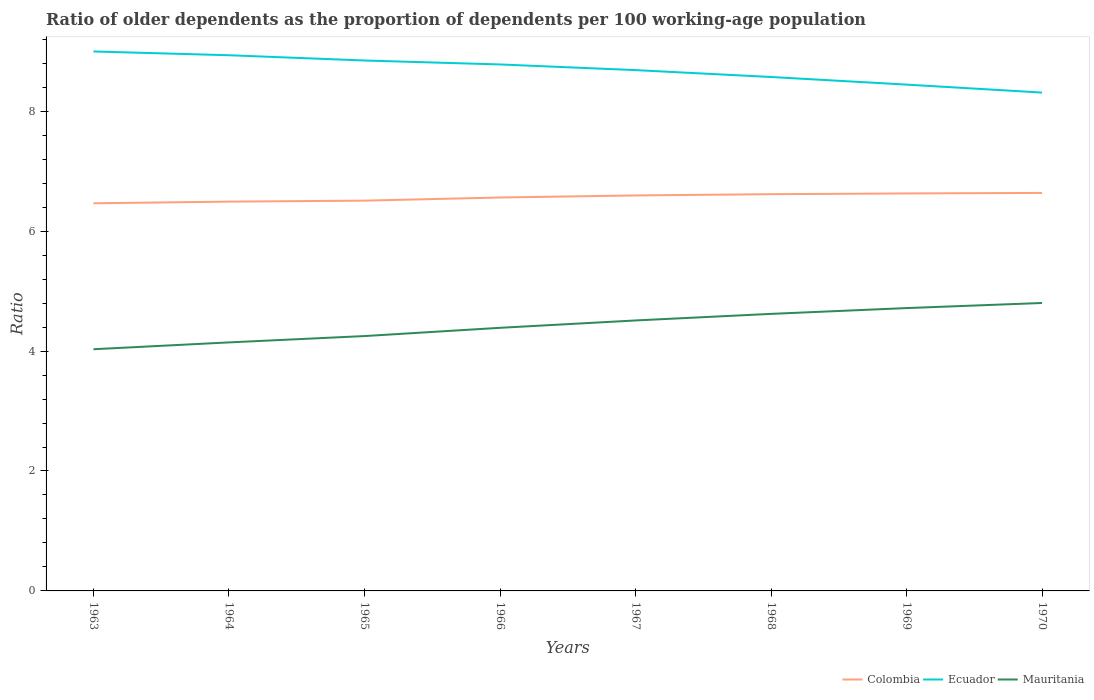How many different coloured lines are there?
Your answer should be very brief. 3. Across all years, what is the maximum age dependency ratio(old) in Colombia?
Offer a terse response. 6.46. In which year was the age dependency ratio(old) in Colombia maximum?
Your answer should be compact. 1963. What is the total age dependency ratio(old) in Colombia in the graph?
Make the answer very short. -0.16. What is the difference between the highest and the second highest age dependency ratio(old) in Mauritania?
Give a very brief answer. 0.77. What is the difference between the highest and the lowest age dependency ratio(old) in Ecuador?
Provide a succinct answer. 4. Is the age dependency ratio(old) in Ecuador strictly greater than the age dependency ratio(old) in Mauritania over the years?
Give a very brief answer. No. How many years are there in the graph?
Make the answer very short. 8. Does the graph contain any zero values?
Your answer should be very brief. No. Does the graph contain grids?
Give a very brief answer. No. What is the title of the graph?
Ensure brevity in your answer.  Ratio of older dependents as the proportion of dependents per 100 working-age population. What is the label or title of the X-axis?
Provide a succinct answer. Years. What is the label or title of the Y-axis?
Keep it short and to the point. Ratio. What is the Ratio of Colombia in 1963?
Offer a very short reply. 6.46. What is the Ratio of Ecuador in 1963?
Your response must be concise. 9. What is the Ratio of Mauritania in 1963?
Your answer should be compact. 4.03. What is the Ratio in Colombia in 1964?
Offer a very short reply. 6.49. What is the Ratio in Ecuador in 1964?
Your answer should be compact. 8.93. What is the Ratio in Mauritania in 1964?
Your answer should be compact. 4.14. What is the Ratio of Colombia in 1965?
Your response must be concise. 6.51. What is the Ratio of Ecuador in 1965?
Give a very brief answer. 8.85. What is the Ratio in Mauritania in 1965?
Keep it short and to the point. 4.25. What is the Ratio of Colombia in 1966?
Ensure brevity in your answer.  6.56. What is the Ratio of Ecuador in 1966?
Give a very brief answer. 8.78. What is the Ratio of Mauritania in 1966?
Your answer should be very brief. 4.39. What is the Ratio of Colombia in 1967?
Provide a succinct answer. 6.6. What is the Ratio of Ecuador in 1967?
Offer a very short reply. 8.69. What is the Ratio of Mauritania in 1967?
Ensure brevity in your answer.  4.51. What is the Ratio in Colombia in 1968?
Provide a short and direct response. 6.62. What is the Ratio in Ecuador in 1968?
Ensure brevity in your answer.  8.57. What is the Ratio of Mauritania in 1968?
Your answer should be very brief. 4.62. What is the Ratio of Colombia in 1969?
Ensure brevity in your answer.  6.63. What is the Ratio of Ecuador in 1969?
Give a very brief answer. 8.44. What is the Ratio of Mauritania in 1969?
Offer a very short reply. 4.72. What is the Ratio in Colombia in 1970?
Provide a short and direct response. 6.64. What is the Ratio of Ecuador in 1970?
Ensure brevity in your answer.  8.31. What is the Ratio in Mauritania in 1970?
Your answer should be very brief. 4.8. Across all years, what is the maximum Ratio of Colombia?
Your answer should be very brief. 6.64. Across all years, what is the maximum Ratio in Ecuador?
Make the answer very short. 9. Across all years, what is the maximum Ratio in Mauritania?
Make the answer very short. 4.8. Across all years, what is the minimum Ratio of Colombia?
Your answer should be compact. 6.46. Across all years, what is the minimum Ratio in Ecuador?
Make the answer very short. 8.31. Across all years, what is the minimum Ratio of Mauritania?
Your response must be concise. 4.03. What is the total Ratio in Colombia in the graph?
Ensure brevity in your answer.  52.5. What is the total Ratio of Ecuador in the graph?
Provide a short and direct response. 69.56. What is the total Ratio of Mauritania in the graph?
Offer a very short reply. 35.46. What is the difference between the Ratio in Colombia in 1963 and that in 1964?
Provide a succinct answer. -0.03. What is the difference between the Ratio in Ecuador in 1963 and that in 1964?
Your answer should be compact. 0.06. What is the difference between the Ratio of Mauritania in 1963 and that in 1964?
Provide a succinct answer. -0.11. What is the difference between the Ratio of Colombia in 1963 and that in 1965?
Ensure brevity in your answer.  -0.04. What is the difference between the Ratio in Ecuador in 1963 and that in 1965?
Give a very brief answer. 0.15. What is the difference between the Ratio of Mauritania in 1963 and that in 1965?
Give a very brief answer. -0.22. What is the difference between the Ratio of Colombia in 1963 and that in 1966?
Ensure brevity in your answer.  -0.1. What is the difference between the Ratio in Ecuador in 1963 and that in 1966?
Keep it short and to the point. 0.22. What is the difference between the Ratio in Mauritania in 1963 and that in 1966?
Ensure brevity in your answer.  -0.36. What is the difference between the Ratio of Colombia in 1963 and that in 1967?
Your answer should be very brief. -0.13. What is the difference between the Ratio in Ecuador in 1963 and that in 1967?
Offer a terse response. 0.31. What is the difference between the Ratio of Mauritania in 1963 and that in 1967?
Give a very brief answer. -0.48. What is the difference between the Ratio in Colombia in 1963 and that in 1968?
Ensure brevity in your answer.  -0.15. What is the difference between the Ratio of Ecuador in 1963 and that in 1968?
Offer a terse response. 0.43. What is the difference between the Ratio in Mauritania in 1963 and that in 1968?
Ensure brevity in your answer.  -0.59. What is the difference between the Ratio of Colombia in 1963 and that in 1969?
Keep it short and to the point. -0.16. What is the difference between the Ratio in Ecuador in 1963 and that in 1969?
Your answer should be compact. 0.55. What is the difference between the Ratio in Mauritania in 1963 and that in 1969?
Offer a terse response. -0.69. What is the difference between the Ratio of Colombia in 1963 and that in 1970?
Offer a terse response. -0.17. What is the difference between the Ratio of Ecuador in 1963 and that in 1970?
Give a very brief answer. 0.69. What is the difference between the Ratio in Mauritania in 1963 and that in 1970?
Give a very brief answer. -0.77. What is the difference between the Ratio in Colombia in 1964 and that in 1965?
Your response must be concise. -0.02. What is the difference between the Ratio of Ecuador in 1964 and that in 1965?
Offer a terse response. 0.09. What is the difference between the Ratio of Mauritania in 1964 and that in 1965?
Your response must be concise. -0.11. What is the difference between the Ratio in Colombia in 1964 and that in 1966?
Your response must be concise. -0.07. What is the difference between the Ratio in Ecuador in 1964 and that in 1966?
Offer a terse response. 0.15. What is the difference between the Ratio of Mauritania in 1964 and that in 1966?
Give a very brief answer. -0.24. What is the difference between the Ratio of Colombia in 1964 and that in 1967?
Keep it short and to the point. -0.1. What is the difference between the Ratio of Ecuador in 1964 and that in 1967?
Make the answer very short. 0.25. What is the difference between the Ratio in Mauritania in 1964 and that in 1967?
Your response must be concise. -0.37. What is the difference between the Ratio in Colombia in 1964 and that in 1968?
Your answer should be compact. -0.12. What is the difference between the Ratio of Ecuador in 1964 and that in 1968?
Give a very brief answer. 0.36. What is the difference between the Ratio of Mauritania in 1964 and that in 1968?
Provide a succinct answer. -0.48. What is the difference between the Ratio in Colombia in 1964 and that in 1969?
Ensure brevity in your answer.  -0.14. What is the difference between the Ratio of Ecuador in 1964 and that in 1969?
Your answer should be compact. 0.49. What is the difference between the Ratio in Mauritania in 1964 and that in 1969?
Make the answer very short. -0.57. What is the difference between the Ratio of Colombia in 1964 and that in 1970?
Your answer should be very brief. -0.15. What is the difference between the Ratio of Ecuador in 1964 and that in 1970?
Your answer should be very brief. 0.62. What is the difference between the Ratio in Mauritania in 1964 and that in 1970?
Give a very brief answer. -0.66. What is the difference between the Ratio of Colombia in 1965 and that in 1966?
Your answer should be compact. -0.05. What is the difference between the Ratio in Ecuador in 1965 and that in 1966?
Provide a succinct answer. 0.07. What is the difference between the Ratio of Mauritania in 1965 and that in 1966?
Make the answer very short. -0.14. What is the difference between the Ratio of Colombia in 1965 and that in 1967?
Offer a very short reply. -0.09. What is the difference between the Ratio of Ecuador in 1965 and that in 1967?
Offer a terse response. 0.16. What is the difference between the Ratio of Mauritania in 1965 and that in 1967?
Your answer should be compact. -0.26. What is the difference between the Ratio in Colombia in 1965 and that in 1968?
Keep it short and to the point. -0.11. What is the difference between the Ratio in Ecuador in 1965 and that in 1968?
Your response must be concise. 0.28. What is the difference between the Ratio in Mauritania in 1965 and that in 1968?
Make the answer very short. -0.37. What is the difference between the Ratio of Colombia in 1965 and that in 1969?
Make the answer very short. -0.12. What is the difference between the Ratio of Ecuador in 1965 and that in 1969?
Ensure brevity in your answer.  0.4. What is the difference between the Ratio of Mauritania in 1965 and that in 1969?
Your answer should be compact. -0.47. What is the difference between the Ratio in Colombia in 1965 and that in 1970?
Offer a terse response. -0.13. What is the difference between the Ratio in Ecuador in 1965 and that in 1970?
Offer a terse response. 0.53. What is the difference between the Ratio in Mauritania in 1965 and that in 1970?
Provide a succinct answer. -0.55. What is the difference between the Ratio of Colombia in 1966 and that in 1967?
Keep it short and to the point. -0.03. What is the difference between the Ratio of Ecuador in 1966 and that in 1967?
Your response must be concise. 0.09. What is the difference between the Ratio in Mauritania in 1966 and that in 1967?
Make the answer very short. -0.12. What is the difference between the Ratio in Colombia in 1966 and that in 1968?
Provide a succinct answer. -0.06. What is the difference between the Ratio in Ecuador in 1966 and that in 1968?
Make the answer very short. 0.21. What is the difference between the Ratio of Mauritania in 1966 and that in 1968?
Make the answer very short. -0.23. What is the difference between the Ratio in Colombia in 1966 and that in 1969?
Make the answer very short. -0.07. What is the difference between the Ratio in Ecuador in 1966 and that in 1969?
Provide a succinct answer. 0.34. What is the difference between the Ratio in Mauritania in 1966 and that in 1969?
Offer a terse response. -0.33. What is the difference between the Ratio of Colombia in 1966 and that in 1970?
Provide a succinct answer. -0.08. What is the difference between the Ratio in Ecuador in 1966 and that in 1970?
Keep it short and to the point. 0.47. What is the difference between the Ratio in Mauritania in 1966 and that in 1970?
Ensure brevity in your answer.  -0.41. What is the difference between the Ratio in Colombia in 1967 and that in 1968?
Provide a short and direct response. -0.02. What is the difference between the Ratio in Ecuador in 1967 and that in 1968?
Offer a terse response. 0.11. What is the difference between the Ratio in Mauritania in 1967 and that in 1968?
Provide a short and direct response. -0.11. What is the difference between the Ratio in Colombia in 1967 and that in 1969?
Ensure brevity in your answer.  -0.03. What is the difference between the Ratio in Ecuador in 1967 and that in 1969?
Your response must be concise. 0.24. What is the difference between the Ratio of Mauritania in 1967 and that in 1969?
Give a very brief answer. -0.21. What is the difference between the Ratio in Colombia in 1967 and that in 1970?
Ensure brevity in your answer.  -0.04. What is the difference between the Ratio in Ecuador in 1967 and that in 1970?
Your answer should be very brief. 0.37. What is the difference between the Ratio of Mauritania in 1967 and that in 1970?
Give a very brief answer. -0.29. What is the difference between the Ratio of Colombia in 1968 and that in 1969?
Offer a terse response. -0.01. What is the difference between the Ratio of Ecuador in 1968 and that in 1969?
Provide a short and direct response. 0.13. What is the difference between the Ratio in Mauritania in 1968 and that in 1969?
Provide a succinct answer. -0.1. What is the difference between the Ratio in Colombia in 1968 and that in 1970?
Offer a terse response. -0.02. What is the difference between the Ratio of Ecuador in 1968 and that in 1970?
Offer a very short reply. 0.26. What is the difference between the Ratio of Mauritania in 1968 and that in 1970?
Make the answer very short. -0.18. What is the difference between the Ratio in Colombia in 1969 and that in 1970?
Provide a succinct answer. -0.01. What is the difference between the Ratio in Ecuador in 1969 and that in 1970?
Provide a short and direct response. 0.13. What is the difference between the Ratio in Mauritania in 1969 and that in 1970?
Provide a short and direct response. -0.08. What is the difference between the Ratio of Colombia in 1963 and the Ratio of Ecuador in 1964?
Offer a very short reply. -2.47. What is the difference between the Ratio in Colombia in 1963 and the Ratio in Mauritania in 1964?
Give a very brief answer. 2.32. What is the difference between the Ratio of Ecuador in 1963 and the Ratio of Mauritania in 1964?
Your answer should be compact. 4.85. What is the difference between the Ratio of Colombia in 1963 and the Ratio of Ecuador in 1965?
Give a very brief answer. -2.38. What is the difference between the Ratio in Colombia in 1963 and the Ratio in Mauritania in 1965?
Your answer should be compact. 2.21. What is the difference between the Ratio in Ecuador in 1963 and the Ratio in Mauritania in 1965?
Give a very brief answer. 4.75. What is the difference between the Ratio in Colombia in 1963 and the Ratio in Ecuador in 1966?
Ensure brevity in your answer.  -2.32. What is the difference between the Ratio in Colombia in 1963 and the Ratio in Mauritania in 1966?
Offer a terse response. 2.08. What is the difference between the Ratio in Ecuador in 1963 and the Ratio in Mauritania in 1966?
Your answer should be very brief. 4.61. What is the difference between the Ratio of Colombia in 1963 and the Ratio of Ecuador in 1967?
Offer a very short reply. -2.22. What is the difference between the Ratio of Colombia in 1963 and the Ratio of Mauritania in 1967?
Make the answer very short. 1.95. What is the difference between the Ratio of Ecuador in 1963 and the Ratio of Mauritania in 1967?
Make the answer very short. 4.49. What is the difference between the Ratio in Colombia in 1963 and the Ratio in Ecuador in 1968?
Keep it short and to the point. -2.11. What is the difference between the Ratio in Colombia in 1963 and the Ratio in Mauritania in 1968?
Keep it short and to the point. 1.84. What is the difference between the Ratio in Ecuador in 1963 and the Ratio in Mauritania in 1968?
Make the answer very short. 4.38. What is the difference between the Ratio of Colombia in 1963 and the Ratio of Ecuador in 1969?
Provide a succinct answer. -1.98. What is the difference between the Ratio in Colombia in 1963 and the Ratio in Mauritania in 1969?
Offer a terse response. 1.75. What is the difference between the Ratio in Ecuador in 1963 and the Ratio in Mauritania in 1969?
Your answer should be very brief. 4.28. What is the difference between the Ratio of Colombia in 1963 and the Ratio of Ecuador in 1970?
Your answer should be very brief. -1.85. What is the difference between the Ratio of Colombia in 1963 and the Ratio of Mauritania in 1970?
Your response must be concise. 1.66. What is the difference between the Ratio of Ecuador in 1963 and the Ratio of Mauritania in 1970?
Your response must be concise. 4.19. What is the difference between the Ratio of Colombia in 1964 and the Ratio of Ecuador in 1965?
Give a very brief answer. -2.35. What is the difference between the Ratio of Colombia in 1964 and the Ratio of Mauritania in 1965?
Offer a terse response. 2.24. What is the difference between the Ratio in Ecuador in 1964 and the Ratio in Mauritania in 1965?
Keep it short and to the point. 4.68. What is the difference between the Ratio of Colombia in 1964 and the Ratio of Ecuador in 1966?
Ensure brevity in your answer.  -2.29. What is the difference between the Ratio of Colombia in 1964 and the Ratio of Mauritania in 1966?
Ensure brevity in your answer.  2.1. What is the difference between the Ratio of Ecuador in 1964 and the Ratio of Mauritania in 1966?
Ensure brevity in your answer.  4.55. What is the difference between the Ratio of Colombia in 1964 and the Ratio of Ecuador in 1967?
Provide a short and direct response. -2.19. What is the difference between the Ratio of Colombia in 1964 and the Ratio of Mauritania in 1967?
Keep it short and to the point. 1.98. What is the difference between the Ratio in Ecuador in 1964 and the Ratio in Mauritania in 1967?
Provide a short and direct response. 4.42. What is the difference between the Ratio of Colombia in 1964 and the Ratio of Ecuador in 1968?
Offer a very short reply. -2.08. What is the difference between the Ratio in Colombia in 1964 and the Ratio in Mauritania in 1968?
Your answer should be compact. 1.87. What is the difference between the Ratio of Ecuador in 1964 and the Ratio of Mauritania in 1968?
Keep it short and to the point. 4.31. What is the difference between the Ratio of Colombia in 1964 and the Ratio of Ecuador in 1969?
Provide a short and direct response. -1.95. What is the difference between the Ratio in Colombia in 1964 and the Ratio in Mauritania in 1969?
Make the answer very short. 1.78. What is the difference between the Ratio in Ecuador in 1964 and the Ratio in Mauritania in 1969?
Your answer should be very brief. 4.22. What is the difference between the Ratio of Colombia in 1964 and the Ratio of Ecuador in 1970?
Your response must be concise. -1.82. What is the difference between the Ratio of Colombia in 1964 and the Ratio of Mauritania in 1970?
Your response must be concise. 1.69. What is the difference between the Ratio in Ecuador in 1964 and the Ratio in Mauritania in 1970?
Ensure brevity in your answer.  4.13. What is the difference between the Ratio of Colombia in 1965 and the Ratio of Ecuador in 1966?
Ensure brevity in your answer.  -2.27. What is the difference between the Ratio of Colombia in 1965 and the Ratio of Mauritania in 1966?
Your answer should be compact. 2.12. What is the difference between the Ratio of Ecuador in 1965 and the Ratio of Mauritania in 1966?
Your response must be concise. 4.46. What is the difference between the Ratio in Colombia in 1965 and the Ratio in Ecuador in 1967?
Provide a short and direct response. -2.18. What is the difference between the Ratio in Colombia in 1965 and the Ratio in Mauritania in 1967?
Keep it short and to the point. 2. What is the difference between the Ratio in Ecuador in 1965 and the Ratio in Mauritania in 1967?
Offer a terse response. 4.34. What is the difference between the Ratio of Colombia in 1965 and the Ratio of Ecuador in 1968?
Provide a short and direct response. -2.06. What is the difference between the Ratio of Colombia in 1965 and the Ratio of Mauritania in 1968?
Your answer should be very brief. 1.89. What is the difference between the Ratio in Ecuador in 1965 and the Ratio in Mauritania in 1968?
Make the answer very short. 4.23. What is the difference between the Ratio of Colombia in 1965 and the Ratio of Ecuador in 1969?
Ensure brevity in your answer.  -1.93. What is the difference between the Ratio in Colombia in 1965 and the Ratio in Mauritania in 1969?
Offer a very short reply. 1.79. What is the difference between the Ratio in Ecuador in 1965 and the Ratio in Mauritania in 1969?
Provide a succinct answer. 4.13. What is the difference between the Ratio in Colombia in 1965 and the Ratio in Ecuador in 1970?
Provide a short and direct response. -1.8. What is the difference between the Ratio in Colombia in 1965 and the Ratio in Mauritania in 1970?
Provide a short and direct response. 1.71. What is the difference between the Ratio in Ecuador in 1965 and the Ratio in Mauritania in 1970?
Your response must be concise. 4.04. What is the difference between the Ratio of Colombia in 1966 and the Ratio of Ecuador in 1967?
Offer a terse response. -2.12. What is the difference between the Ratio of Colombia in 1966 and the Ratio of Mauritania in 1967?
Your answer should be compact. 2.05. What is the difference between the Ratio in Ecuador in 1966 and the Ratio in Mauritania in 1967?
Your answer should be very brief. 4.27. What is the difference between the Ratio of Colombia in 1966 and the Ratio of Ecuador in 1968?
Offer a very short reply. -2.01. What is the difference between the Ratio in Colombia in 1966 and the Ratio in Mauritania in 1968?
Make the answer very short. 1.94. What is the difference between the Ratio in Ecuador in 1966 and the Ratio in Mauritania in 1968?
Offer a terse response. 4.16. What is the difference between the Ratio in Colombia in 1966 and the Ratio in Ecuador in 1969?
Make the answer very short. -1.88. What is the difference between the Ratio of Colombia in 1966 and the Ratio of Mauritania in 1969?
Ensure brevity in your answer.  1.84. What is the difference between the Ratio in Ecuador in 1966 and the Ratio in Mauritania in 1969?
Offer a very short reply. 4.06. What is the difference between the Ratio of Colombia in 1966 and the Ratio of Ecuador in 1970?
Your answer should be very brief. -1.75. What is the difference between the Ratio in Colombia in 1966 and the Ratio in Mauritania in 1970?
Keep it short and to the point. 1.76. What is the difference between the Ratio of Ecuador in 1966 and the Ratio of Mauritania in 1970?
Provide a short and direct response. 3.98. What is the difference between the Ratio in Colombia in 1967 and the Ratio in Ecuador in 1968?
Offer a terse response. -1.98. What is the difference between the Ratio of Colombia in 1967 and the Ratio of Mauritania in 1968?
Provide a succinct answer. 1.98. What is the difference between the Ratio of Ecuador in 1967 and the Ratio of Mauritania in 1968?
Make the answer very short. 4.07. What is the difference between the Ratio of Colombia in 1967 and the Ratio of Ecuador in 1969?
Provide a short and direct response. -1.85. What is the difference between the Ratio in Colombia in 1967 and the Ratio in Mauritania in 1969?
Keep it short and to the point. 1.88. What is the difference between the Ratio in Ecuador in 1967 and the Ratio in Mauritania in 1969?
Ensure brevity in your answer.  3.97. What is the difference between the Ratio of Colombia in 1967 and the Ratio of Ecuador in 1970?
Make the answer very short. -1.72. What is the difference between the Ratio in Colombia in 1967 and the Ratio in Mauritania in 1970?
Your answer should be very brief. 1.79. What is the difference between the Ratio of Ecuador in 1967 and the Ratio of Mauritania in 1970?
Ensure brevity in your answer.  3.88. What is the difference between the Ratio of Colombia in 1968 and the Ratio of Ecuador in 1969?
Offer a very short reply. -1.83. What is the difference between the Ratio in Colombia in 1968 and the Ratio in Mauritania in 1969?
Provide a succinct answer. 1.9. What is the difference between the Ratio of Ecuador in 1968 and the Ratio of Mauritania in 1969?
Ensure brevity in your answer.  3.85. What is the difference between the Ratio in Colombia in 1968 and the Ratio in Ecuador in 1970?
Provide a short and direct response. -1.69. What is the difference between the Ratio in Colombia in 1968 and the Ratio in Mauritania in 1970?
Your answer should be very brief. 1.81. What is the difference between the Ratio in Ecuador in 1968 and the Ratio in Mauritania in 1970?
Make the answer very short. 3.77. What is the difference between the Ratio of Colombia in 1969 and the Ratio of Ecuador in 1970?
Offer a terse response. -1.68. What is the difference between the Ratio in Colombia in 1969 and the Ratio in Mauritania in 1970?
Provide a short and direct response. 1.83. What is the difference between the Ratio of Ecuador in 1969 and the Ratio of Mauritania in 1970?
Ensure brevity in your answer.  3.64. What is the average Ratio of Colombia per year?
Your response must be concise. 6.56. What is the average Ratio of Ecuador per year?
Your response must be concise. 8.7. What is the average Ratio of Mauritania per year?
Your answer should be compact. 4.43. In the year 1963, what is the difference between the Ratio in Colombia and Ratio in Ecuador?
Provide a succinct answer. -2.53. In the year 1963, what is the difference between the Ratio of Colombia and Ratio of Mauritania?
Provide a short and direct response. 2.43. In the year 1963, what is the difference between the Ratio in Ecuador and Ratio in Mauritania?
Ensure brevity in your answer.  4.97. In the year 1964, what is the difference between the Ratio of Colombia and Ratio of Ecuador?
Your answer should be compact. -2.44. In the year 1964, what is the difference between the Ratio of Colombia and Ratio of Mauritania?
Give a very brief answer. 2.35. In the year 1964, what is the difference between the Ratio of Ecuador and Ratio of Mauritania?
Make the answer very short. 4.79. In the year 1965, what is the difference between the Ratio in Colombia and Ratio in Ecuador?
Ensure brevity in your answer.  -2.34. In the year 1965, what is the difference between the Ratio of Colombia and Ratio of Mauritania?
Your answer should be compact. 2.26. In the year 1965, what is the difference between the Ratio in Ecuador and Ratio in Mauritania?
Provide a short and direct response. 4.6. In the year 1966, what is the difference between the Ratio in Colombia and Ratio in Ecuador?
Give a very brief answer. -2.22. In the year 1966, what is the difference between the Ratio in Colombia and Ratio in Mauritania?
Keep it short and to the point. 2.17. In the year 1966, what is the difference between the Ratio in Ecuador and Ratio in Mauritania?
Your answer should be compact. 4.39. In the year 1967, what is the difference between the Ratio in Colombia and Ratio in Ecuador?
Offer a terse response. -2.09. In the year 1967, what is the difference between the Ratio in Colombia and Ratio in Mauritania?
Provide a succinct answer. 2.08. In the year 1967, what is the difference between the Ratio in Ecuador and Ratio in Mauritania?
Offer a terse response. 4.17. In the year 1968, what is the difference between the Ratio of Colombia and Ratio of Ecuador?
Ensure brevity in your answer.  -1.95. In the year 1968, what is the difference between the Ratio of Colombia and Ratio of Mauritania?
Your answer should be very brief. 2. In the year 1968, what is the difference between the Ratio in Ecuador and Ratio in Mauritania?
Make the answer very short. 3.95. In the year 1969, what is the difference between the Ratio of Colombia and Ratio of Ecuador?
Keep it short and to the point. -1.81. In the year 1969, what is the difference between the Ratio of Colombia and Ratio of Mauritania?
Offer a very short reply. 1.91. In the year 1969, what is the difference between the Ratio in Ecuador and Ratio in Mauritania?
Offer a terse response. 3.73. In the year 1970, what is the difference between the Ratio in Colombia and Ratio in Ecuador?
Give a very brief answer. -1.67. In the year 1970, what is the difference between the Ratio of Colombia and Ratio of Mauritania?
Offer a terse response. 1.84. In the year 1970, what is the difference between the Ratio in Ecuador and Ratio in Mauritania?
Your answer should be very brief. 3.51. What is the ratio of the Ratio in Ecuador in 1963 to that in 1964?
Make the answer very short. 1.01. What is the ratio of the Ratio in Mauritania in 1963 to that in 1964?
Give a very brief answer. 0.97. What is the ratio of the Ratio of Mauritania in 1963 to that in 1965?
Your response must be concise. 0.95. What is the ratio of the Ratio of Ecuador in 1963 to that in 1966?
Provide a short and direct response. 1.02. What is the ratio of the Ratio of Mauritania in 1963 to that in 1966?
Your answer should be very brief. 0.92. What is the ratio of the Ratio in Colombia in 1963 to that in 1967?
Your answer should be compact. 0.98. What is the ratio of the Ratio in Ecuador in 1963 to that in 1967?
Make the answer very short. 1.04. What is the ratio of the Ratio in Mauritania in 1963 to that in 1967?
Ensure brevity in your answer.  0.89. What is the ratio of the Ratio of Colombia in 1963 to that in 1968?
Provide a succinct answer. 0.98. What is the ratio of the Ratio in Ecuador in 1963 to that in 1968?
Your answer should be compact. 1.05. What is the ratio of the Ratio in Mauritania in 1963 to that in 1968?
Keep it short and to the point. 0.87. What is the ratio of the Ratio of Colombia in 1963 to that in 1969?
Ensure brevity in your answer.  0.98. What is the ratio of the Ratio of Ecuador in 1963 to that in 1969?
Give a very brief answer. 1.07. What is the ratio of the Ratio of Mauritania in 1963 to that in 1969?
Keep it short and to the point. 0.85. What is the ratio of the Ratio in Colombia in 1963 to that in 1970?
Provide a succinct answer. 0.97. What is the ratio of the Ratio of Ecuador in 1963 to that in 1970?
Offer a very short reply. 1.08. What is the ratio of the Ratio in Mauritania in 1963 to that in 1970?
Keep it short and to the point. 0.84. What is the ratio of the Ratio in Ecuador in 1964 to that in 1965?
Your answer should be compact. 1.01. What is the ratio of the Ratio of Mauritania in 1964 to that in 1965?
Provide a short and direct response. 0.98. What is the ratio of the Ratio in Colombia in 1964 to that in 1966?
Offer a very short reply. 0.99. What is the ratio of the Ratio in Ecuador in 1964 to that in 1966?
Your response must be concise. 1.02. What is the ratio of the Ratio of Mauritania in 1964 to that in 1966?
Keep it short and to the point. 0.94. What is the ratio of the Ratio in Colombia in 1964 to that in 1967?
Make the answer very short. 0.98. What is the ratio of the Ratio of Ecuador in 1964 to that in 1967?
Provide a short and direct response. 1.03. What is the ratio of the Ratio in Mauritania in 1964 to that in 1967?
Provide a short and direct response. 0.92. What is the ratio of the Ratio in Colombia in 1964 to that in 1968?
Your answer should be very brief. 0.98. What is the ratio of the Ratio of Ecuador in 1964 to that in 1968?
Ensure brevity in your answer.  1.04. What is the ratio of the Ratio of Mauritania in 1964 to that in 1968?
Your answer should be compact. 0.9. What is the ratio of the Ratio of Colombia in 1964 to that in 1969?
Ensure brevity in your answer.  0.98. What is the ratio of the Ratio in Ecuador in 1964 to that in 1969?
Make the answer very short. 1.06. What is the ratio of the Ratio of Mauritania in 1964 to that in 1969?
Your answer should be compact. 0.88. What is the ratio of the Ratio in Colombia in 1964 to that in 1970?
Offer a very short reply. 0.98. What is the ratio of the Ratio of Ecuador in 1964 to that in 1970?
Provide a succinct answer. 1.07. What is the ratio of the Ratio in Mauritania in 1964 to that in 1970?
Your answer should be compact. 0.86. What is the ratio of the Ratio of Colombia in 1965 to that in 1966?
Provide a short and direct response. 0.99. What is the ratio of the Ratio in Ecuador in 1965 to that in 1966?
Your answer should be very brief. 1.01. What is the ratio of the Ratio in Mauritania in 1965 to that in 1966?
Give a very brief answer. 0.97. What is the ratio of the Ratio in Ecuador in 1965 to that in 1967?
Make the answer very short. 1.02. What is the ratio of the Ratio of Mauritania in 1965 to that in 1967?
Make the answer very short. 0.94. What is the ratio of the Ratio in Colombia in 1965 to that in 1968?
Keep it short and to the point. 0.98. What is the ratio of the Ratio of Ecuador in 1965 to that in 1968?
Offer a terse response. 1.03. What is the ratio of the Ratio of Mauritania in 1965 to that in 1968?
Provide a short and direct response. 0.92. What is the ratio of the Ratio of Colombia in 1965 to that in 1969?
Offer a terse response. 0.98. What is the ratio of the Ratio in Ecuador in 1965 to that in 1969?
Your answer should be very brief. 1.05. What is the ratio of the Ratio in Mauritania in 1965 to that in 1969?
Your answer should be compact. 0.9. What is the ratio of the Ratio of Colombia in 1965 to that in 1970?
Provide a succinct answer. 0.98. What is the ratio of the Ratio in Ecuador in 1965 to that in 1970?
Provide a short and direct response. 1.06. What is the ratio of the Ratio in Mauritania in 1965 to that in 1970?
Provide a short and direct response. 0.89. What is the ratio of the Ratio in Ecuador in 1966 to that in 1967?
Provide a short and direct response. 1.01. What is the ratio of the Ratio in Mauritania in 1966 to that in 1967?
Offer a very short reply. 0.97. What is the ratio of the Ratio of Ecuador in 1966 to that in 1968?
Offer a terse response. 1.02. What is the ratio of the Ratio in Mauritania in 1966 to that in 1968?
Offer a terse response. 0.95. What is the ratio of the Ratio of Colombia in 1966 to that in 1969?
Provide a succinct answer. 0.99. What is the ratio of the Ratio of Ecuador in 1966 to that in 1969?
Your answer should be very brief. 1.04. What is the ratio of the Ratio in Mauritania in 1966 to that in 1969?
Make the answer very short. 0.93. What is the ratio of the Ratio of Colombia in 1966 to that in 1970?
Ensure brevity in your answer.  0.99. What is the ratio of the Ratio of Ecuador in 1966 to that in 1970?
Provide a short and direct response. 1.06. What is the ratio of the Ratio in Mauritania in 1966 to that in 1970?
Your answer should be very brief. 0.91. What is the ratio of the Ratio of Ecuador in 1967 to that in 1968?
Offer a terse response. 1.01. What is the ratio of the Ratio in Mauritania in 1967 to that in 1968?
Make the answer very short. 0.98. What is the ratio of the Ratio in Colombia in 1967 to that in 1969?
Your answer should be compact. 0.99. What is the ratio of the Ratio in Ecuador in 1967 to that in 1969?
Keep it short and to the point. 1.03. What is the ratio of the Ratio in Mauritania in 1967 to that in 1969?
Your answer should be compact. 0.96. What is the ratio of the Ratio of Colombia in 1967 to that in 1970?
Your response must be concise. 0.99. What is the ratio of the Ratio of Ecuador in 1967 to that in 1970?
Give a very brief answer. 1.05. What is the ratio of the Ratio in Mauritania in 1967 to that in 1970?
Make the answer very short. 0.94. What is the ratio of the Ratio in Colombia in 1968 to that in 1969?
Provide a succinct answer. 1. What is the ratio of the Ratio of Ecuador in 1968 to that in 1969?
Your answer should be compact. 1.01. What is the ratio of the Ratio of Mauritania in 1968 to that in 1969?
Offer a very short reply. 0.98. What is the ratio of the Ratio in Colombia in 1968 to that in 1970?
Offer a terse response. 1. What is the ratio of the Ratio in Ecuador in 1968 to that in 1970?
Your answer should be compact. 1.03. What is the ratio of the Ratio of Mauritania in 1968 to that in 1970?
Your answer should be compact. 0.96. What is the ratio of the Ratio in Mauritania in 1969 to that in 1970?
Your response must be concise. 0.98. What is the difference between the highest and the second highest Ratio in Colombia?
Ensure brevity in your answer.  0.01. What is the difference between the highest and the second highest Ratio of Ecuador?
Make the answer very short. 0.06. What is the difference between the highest and the second highest Ratio in Mauritania?
Offer a terse response. 0.08. What is the difference between the highest and the lowest Ratio in Colombia?
Your answer should be compact. 0.17. What is the difference between the highest and the lowest Ratio in Ecuador?
Ensure brevity in your answer.  0.69. What is the difference between the highest and the lowest Ratio of Mauritania?
Keep it short and to the point. 0.77. 